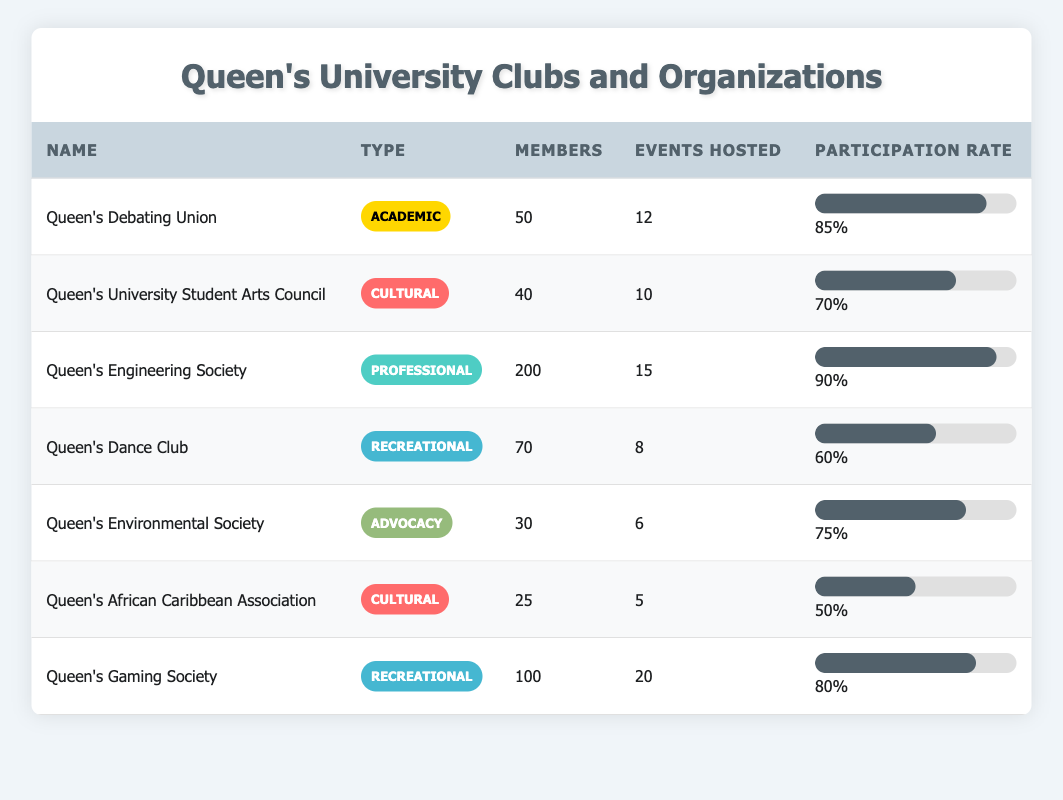What is the total number of members in all clubs listed? To find the total number of members, we add together the members of each club: 50 (Debating Union) + 40 (Arts Council) + 200 (Engineering Society) + 70 (Dance Club) + 30 (Environmental Society) + 25 (African Caribbean Association) + 100 (Gaming Society) = 515.
Answer: 515 Which club has the highest participation rate? By comparing the Participation Rates: Queen's Engineering Society (90%), Queen's Debating Union (85%), Queen's Gaming Society (80%), Queen’s Environmental Society (75%), Queen's University Student Arts Council (70%), Queen's Dance Club (60%), and Queen's African Caribbean Association (50%), the club with the highest participation rate is Queen's Engineering Society at 90%.
Answer: Queen's Engineering Society Is the Queen's Dance Club a cultural organization? The Queen's Dance Club is classified as a Recreational club, not a Cultural one based on the table's classification of types.
Answer: No What is the average participation rate for the clubs categorized as Recreational? The clubs in the Recreational category are Queen's Dance Club (60%) and Queen's Gaming Society (80%). To find the average, we sum their participation rates: 60 + 80 = 140, then divide by the number of clubs: 140 / 2 = 70%.
Answer: 70% How many events were hosted by the Queen's African Caribbean Association? The table shows that Queen's African Caribbean Association hosted 5 events. Thus, the answer is directly taken from the table.
Answer: 5 What fraction of the total members are from the Queen's Engineering Society? The total number of members is 515 (as calculated before). The Queen's Engineering Society has 200 members. Therefore, the fraction is 200/515. Simplifying this fraction is complex without a calculator, but it approximates to roughly 0.388.
Answer: 200/515 Are there more members in the Cultural clubs than in the Advocacy clubs? The Cultural clubs, Queen's University Student Arts Council (40 members) and Queen's African Caribbean Association (25 members), total to 65 members. The Advocacy club, Queen's Environmental Society, has 30 members. Since 65 > 30, there are indeed more members in the Cultural clubs.
Answer: Yes Which type of club has hosted the most events overall? Summing the events hosted by each type: Academic (12), Cultural (10), Professional (15), Recreational (20), Advocacy (6). Adding these numbers shows that Recreational clubs had the most events hosted: 20 vs others.
Answer: Recreational 